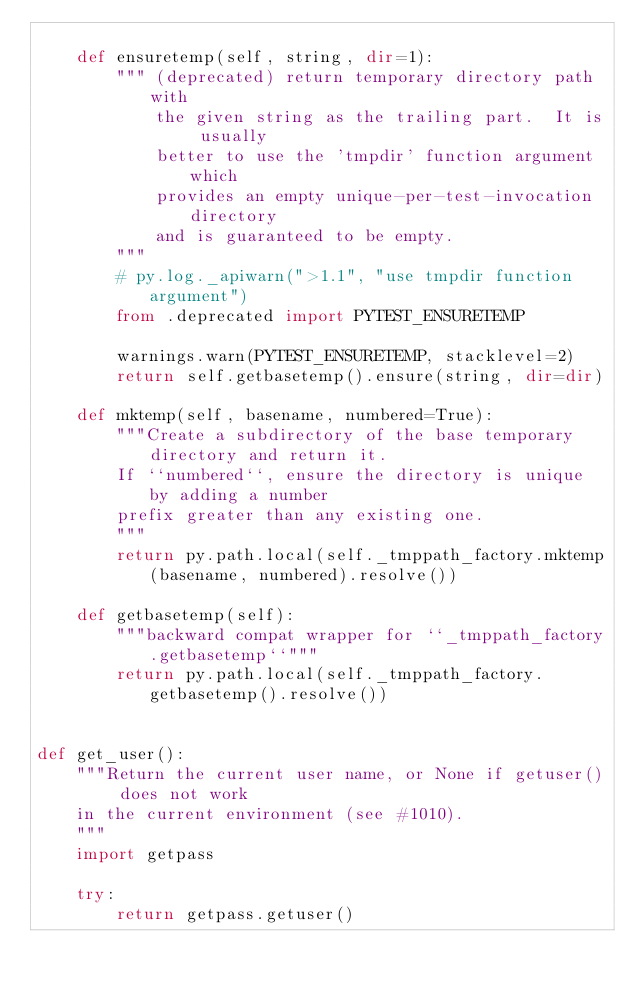<code> <loc_0><loc_0><loc_500><loc_500><_Python_>
    def ensuretemp(self, string, dir=1):
        """ (deprecated) return temporary directory path with
            the given string as the trailing part.  It is usually
            better to use the 'tmpdir' function argument which
            provides an empty unique-per-test-invocation directory
            and is guaranteed to be empty.
        """
        # py.log._apiwarn(">1.1", "use tmpdir function argument")
        from .deprecated import PYTEST_ENSURETEMP

        warnings.warn(PYTEST_ENSURETEMP, stacklevel=2)
        return self.getbasetemp().ensure(string, dir=dir)

    def mktemp(self, basename, numbered=True):
        """Create a subdirectory of the base temporary directory and return it.
        If ``numbered``, ensure the directory is unique by adding a number
        prefix greater than any existing one.
        """
        return py.path.local(self._tmppath_factory.mktemp(basename, numbered).resolve())

    def getbasetemp(self):
        """backward compat wrapper for ``_tmppath_factory.getbasetemp``"""
        return py.path.local(self._tmppath_factory.getbasetemp().resolve())


def get_user():
    """Return the current user name, or None if getuser() does not work
    in the current environment (see #1010).
    """
    import getpass

    try:
        return getpass.getuser()</code> 